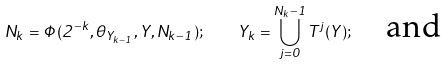Convert formula to latex. <formula><loc_0><loc_0><loc_500><loc_500>N _ { k } = \Phi ( 2 ^ { - k } , \theta _ { Y _ { k - 1 } } , Y , N _ { k - 1 } ) ; \quad Y _ { k } = \bigcup _ { j = 0 } ^ { N _ { k } - 1 } T ^ { j } ( Y ) ; \quad \text {and}</formula> 